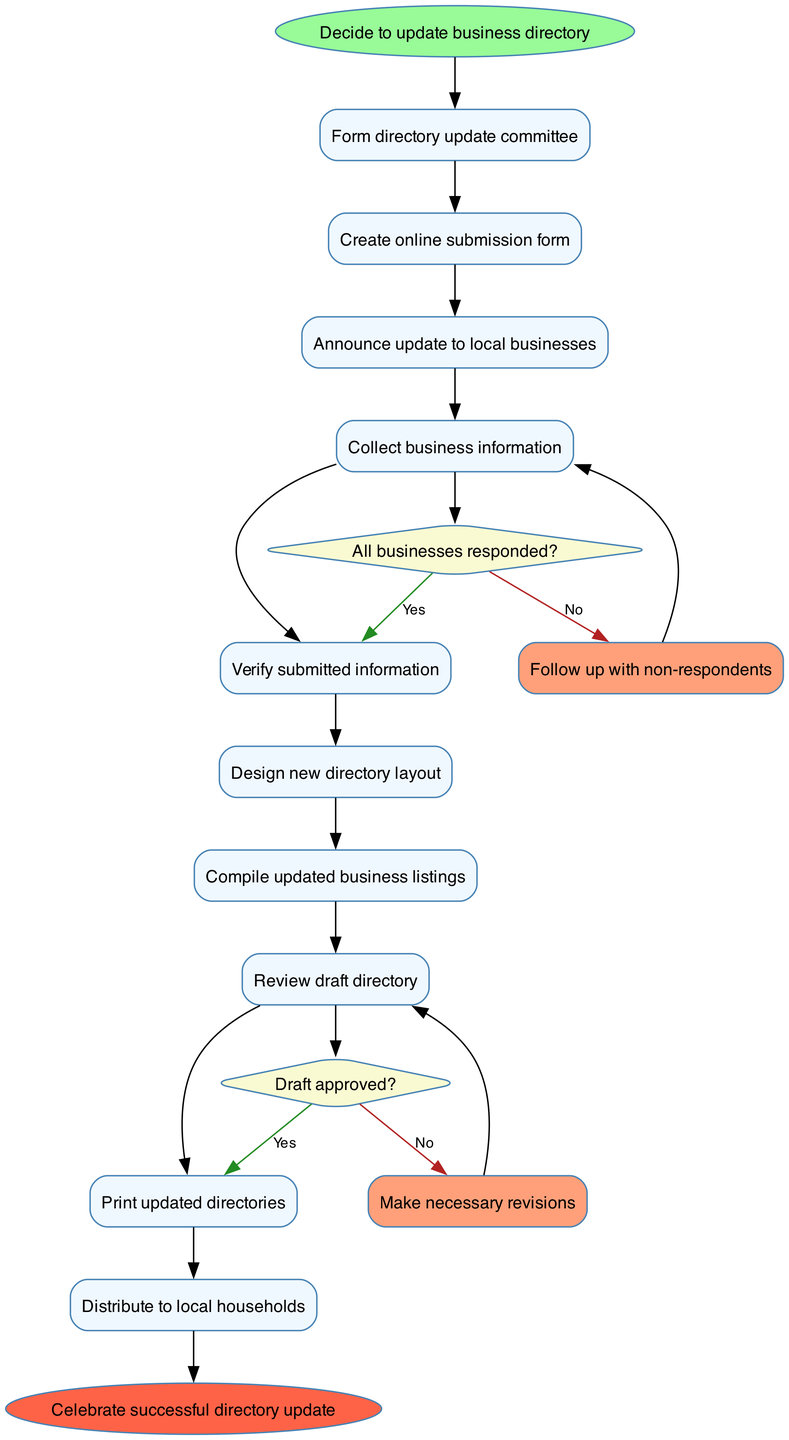What is the first activity in the diagram? The first activity is labeled following the start node, which is "Form directory update committee."
Answer: Form directory update committee How many activities are listed in the diagram? There are a total of 10 activities, as listed sequentially from the start node to the end node.
Answer: 10 What happens if all businesses respond? If all businesses respond, the next step in the sequence is to "Verify submitted information" according to the decision node's 'Yes' outcome.
Answer: Verify submitted information What is the decision made after reviewing the draft directory? The decision made after reviewing the draft directory is whether the draft is approved. The 'Yes' outcome leads to the activity of printing updated directories.
Answer: Draft approved? What is the end node of the diagram? The end node after all processes are completed is "Celebrate successful directory update", which signifies the conclusion of the update process.
Answer: Celebrate successful directory update What follows the activity "Collect business information"? After "Collect business information," the decision point is reached regarding whether all businesses responded, leading to the "Verify submitted information" activity if they did respond.
Answer: Verify submitted information If not all businesses responded, what is the subsequent action? The subsequent action for the 'No' outcome at the decision node regarding business responses is to "Follow up with non-respondents" to encourage participation.
Answer: Follow up with non-respondents What is the color used for the end node? The end node is colored in red, indicated as '#FF6347' which visually represents its importance within the flow of the diagram.
Answer: Red How many decision nodes are in the diagram? There are 2 decision nodes present in the diagram, each corresponding to a specific decision point in the process.
Answer: 2 What is the last activity before the end node? The last activity before reaching the end node is "Distribute to local households", marking the final step in the update process.
Answer: Distribute to local households 